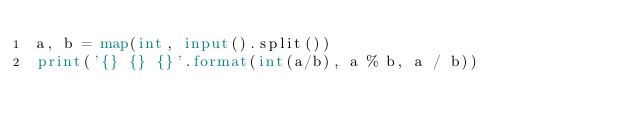<code> <loc_0><loc_0><loc_500><loc_500><_Python_>a, b = map(int, input().split())
print('{} {} {}'.format(int(a/b), a % b, a / b))

</code> 